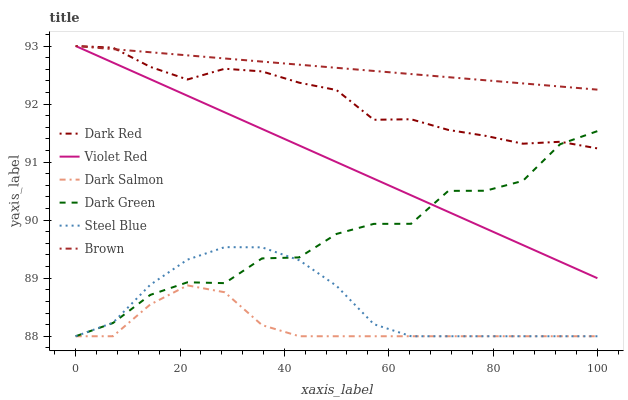Does Dark Salmon have the minimum area under the curve?
Answer yes or no. Yes. Does Brown have the maximum area under the curve?
Answer yes or no. Yes. Does Violet Red have the minimum area under the curve?
Answer yes or no. No. Does Violet Red have the maximum area under the curve?
Answer yes or no. No. Is Brown the smoothest?
Answer yes or no. Yes. Is Dark Green the roughest?
Answer yes or no. Yes. Is Violet Red the smoothest?
Answer yes or no. No. Is Violet Red the roughest?
Answer yes or no. No. Does Dark Salmon have the lowest value?
Answer yes or no. Yes. Does Violet Red have the lowest value?
Answer yes or no. No. Does Dark Red have the highest value?
Answer yes or no. Yes. Does Dark Salmon have the highest value?
Answer yes or no. No. Is Dark Salmon less than Brown?
Answer yes or no. Yes. Is Brown greater than Dark Green?
Answer yes or no. Yes. Does Dark Salmon intersect Steel Blue?
Answer yes or no. Yes. Is Dark Salmon less than Steel Blue?
Answer yes or no. No. Is Dark Salmon greater than Steel Blue?
Answer yes or no. No. Does Dark Salmon intersect Brown?
Answer yes or no. No. 